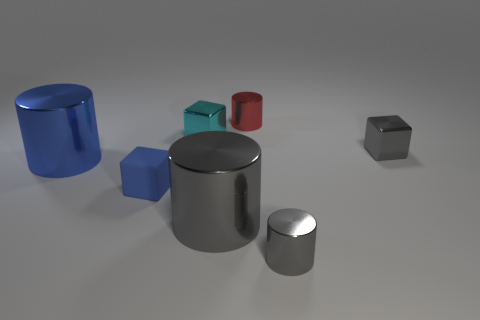What could be the context or purpose of these objects being arranged this way? The objects could be part of a visualization in a study of geometry, showcasing different shapes and sizes to compare their properties. Alternatively, it might be an artistic composition focusing on minimalism and color contrasts. 